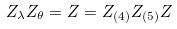Convert formula to latex. <formula><loc_0><loc_0><loc_500><loc_500>Z _ { \lambda } Z _ { \theta } = Z = Z _ { ( 4 ) } Z _ { ( 5 ) } Z</formula> 